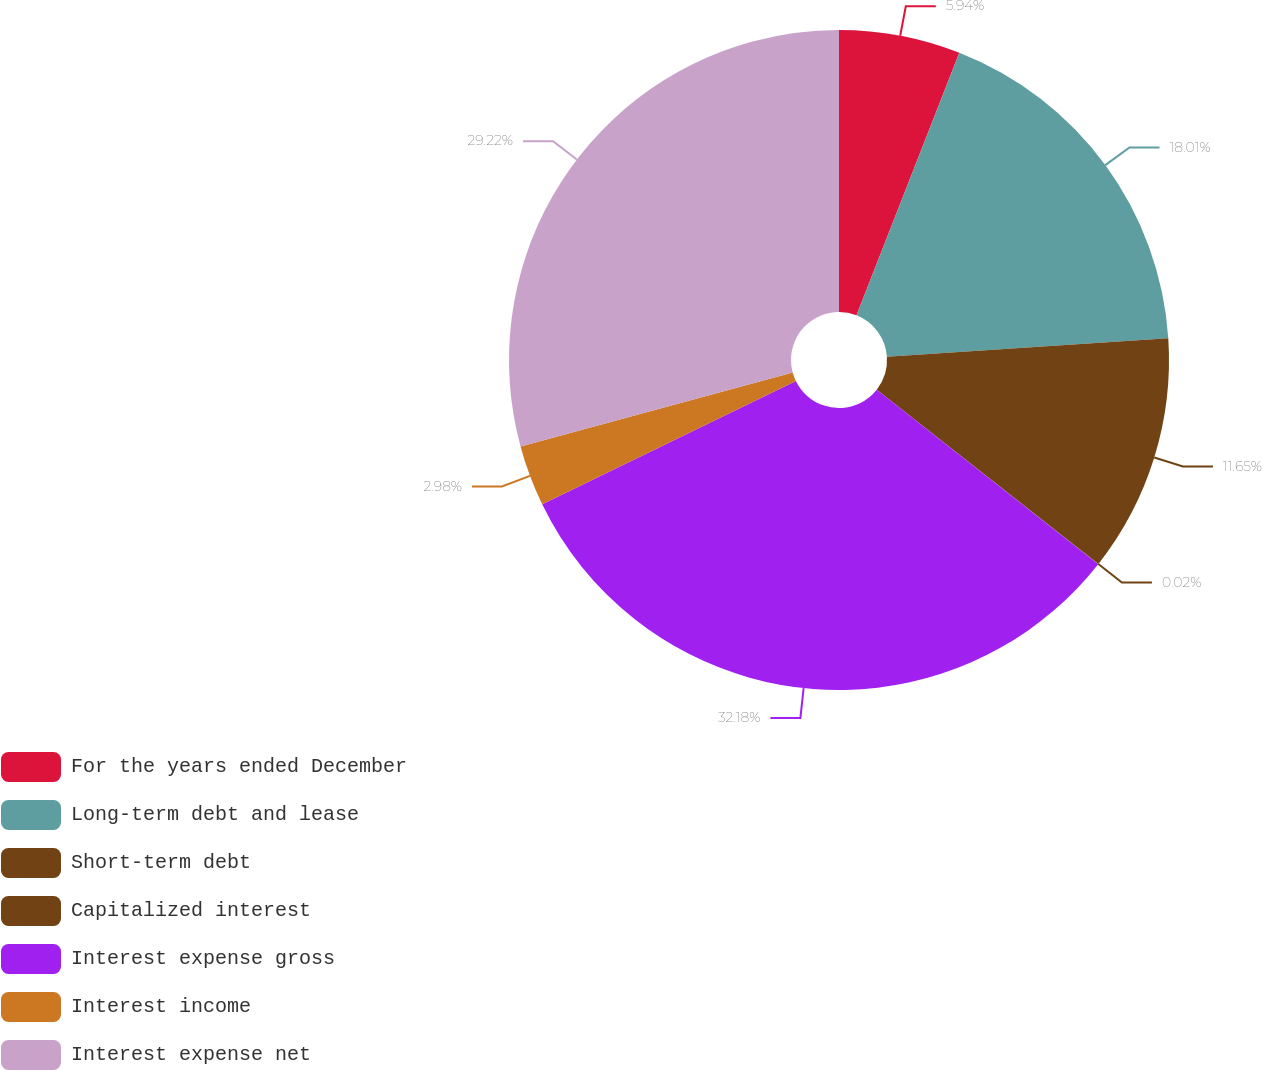Convert chart. <chart><loc_0><loc_0><loc_500><loc_500><pie_chart><fcel>For the years ended December<fcel>Long-term debt and lease<fcel>Short-term debt<fcel>Capitalized interest<fcel>Interest expense gross<fcel>Interest income<fcel>Interest expense net<nl><fcel>5.94%<fcel>18.01%<fcel>11.65%<fcel>0.02%<fcel>32.18%<fcel>2.98%<fcel>29.22%<nl></chart> 